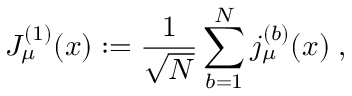<formula> <loc_0><loc_0><loc_500><loc_500>J _ { \mu } ^ { ( 1 ) } ( x ) \colon = \frac { 1 } { \sqrt { N } } \sum _ { b = 1 } ^ { N } j _ { \mu } ^ { ( b ) } ( x ) \, ,</formula> 